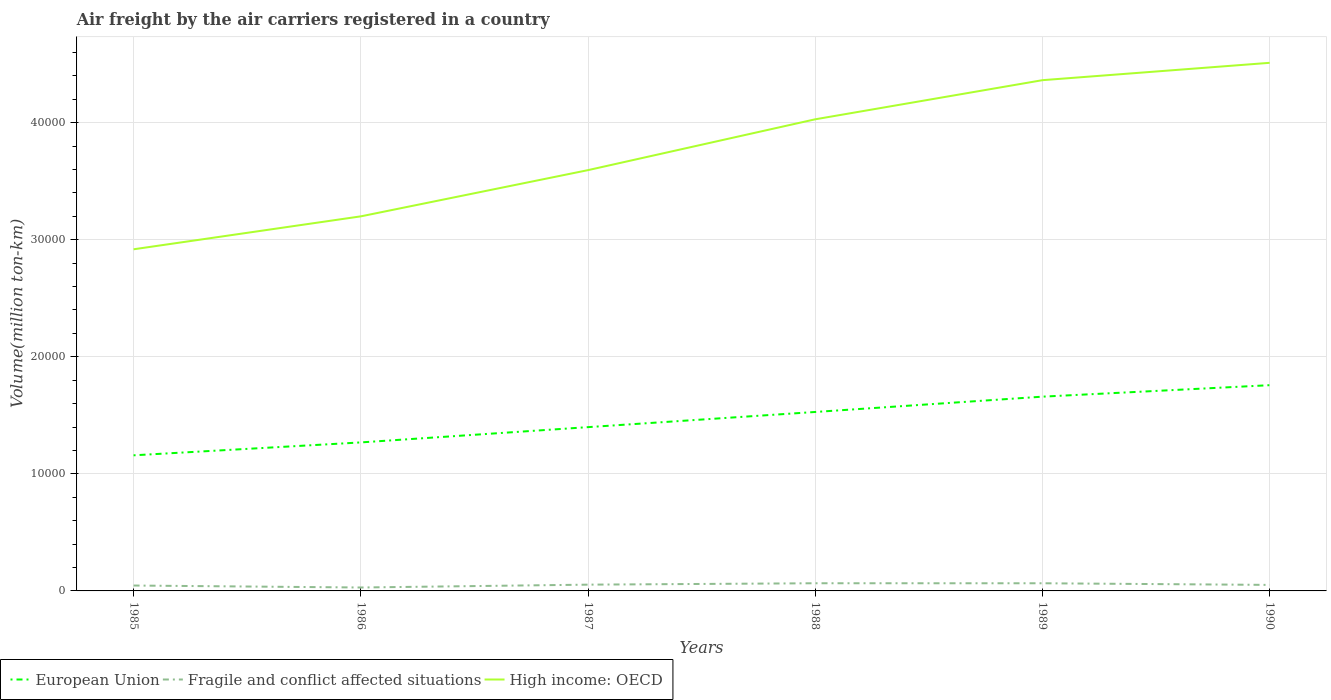Does the line corresponding to High income: OECD intersect with the line corresponding to European Union?
Your response must be concise. No. Across all years, what is the maximum volume of the air carriers in Fragile and conflict affected situations?
Give a very brief answer. 292. What is the total volume of the air carriers in Fragile and conflict affected situations in the graph?
Offer a very short reply. -54. What is the difference between the highest and the second highest volume of the air carriers in Fragile and conflict affected situations?
Offer a very short reply. 363.2. What is the difference between the highest and the lowest volume of the air carriers in European Union?
Ensure brevity in your answer.  3. Is the volume of the air carriers in European Union strictly greater than the volume of the air carriers in High income: OECD over the years?
Your response must be concise. Yes. How many lines are there?
Your answer should be compact. 3. How many years are there in the graph?
Offer a very short reply. 6. What is the difference between two consecutive major ticks on the Y-axis?
Provide a succinct answer. 10000. Does the graph contain any zero values?
Provide a succinct answer. No. Does the graph contain grids?
Make the answer very short. Yes. Where does the legend appear in the graph?
Your answer should be compact. Bottom left. How many legend labels are there?
Make the answer very short. 3. What is the title of the graph?
Give a very brief answer. Air freight by the air carriers registered in a country. What is the label or title of the X-axis?
Keep it short and to the point. Years. What is the label or title of the Y-axis?
Keep it short and to the point. Volume(million ton-km). What is the Volume(million ton-km) in European Union in 1985?
Provide a succinct answer. 1.16e+04. What is the Volume(million ton-km) in Fragile and conflict affected situations in 1985?
Your response must be concise. 460.4. What is the Volume(million ton-km) in High income: OECD in 1985?
Your answer should be very brief. 2.92e+04. What is the Volume(million ton-km) of European Union in 1986?
Give a very brief answer. 1.27e+04. What is the Volume(million ton-km) of Fragile and conflict affected situations in 1986?
Offer a very short reply. 292. What is the Volume(million ton-km) of High income: OECD in 1986?
Keep it short and to the point. 3.20e+04. What is the Volume(million ton-km) of European Union in 1987?
Ensure brevity in your answer.  1.40e+04. What is the Volume(million ton-km) in Fragile and conflict affected situations in 1987?
Ensure brevity in your answer.  536. What is the Volume(million ton-km) in High income: OECD in 1987?
Ensure brevity in your answer.  3.59e+04. What is the Volume(million ton-km) of European Union in 1988?
Offer a very short reply. 1.53e+04. What is the Volume(million ton-km) of Fragile and conflict affected situations in 1988?
Keep it short and to the point. 655.2. What is the Volume(million ton-km) in High income: OECD in 1988?
Make the answer very short. 4.03e+04. What is the Volume(million ton-km) of European Union in 1989?
Offer a very short reply. 1.66e+04. What is the Volume(million ton-km) of Fragile and conflict affected situations in 1989?
Your response must be concise. 653.9. What is the Volume(million ton-km) of High income: OECD in 1989?
Keep it short and to the point. 4.36e+04. What is the Volume(million ton-km) in European Union in 1990?
Provide a succinct answer. 1.76e+04. What is the Volume(million ton-km) in Fragile and conflict affected situations in 1990?
Offer a very short reply. 514.4. What is the Volume(million ton-km) in High income: OECD in 1990?
Keep it short and to the point. 4.51e+04. Across all years, what is the maximum Volume(million ton-km) in European Union?
Your response must be concise. 1.76e+04. Across all years, what is the maximum Volume(million ton-km) in Fragile and conflict affected situations?
Offer a very short reply. 655.2. Across all years, what is the maximum Volume(million ton-km) in High income: OECD?
Your answer should be compact. 4.51e+04. Across all years, what is the minimum Volume(million ton-km) of European Union?
Ensure brevity in your answer.  1.16e+04. Across all years, what is the minimum Volume(million ton-km) in Fragile and conflict affected situations?
Make the answer very short. 292. Across all years, what is the minimum Volume(million ton-km) of High income: OECD?
Provide a short and direct response. 2.92e+04. What is the total Volume(million ton-km) of European Union in the graph?
Ensure brevity in your answer.  8.77e+04. What is the total Volume(million ton-km) of Fragile and conflict affected situations in the graph?
Give a very brief answer. 3111.9. What is the total Volume(million ton-km) in High income: OECD in the graph?
Offer a very short reply. 2.26e+05. What is the difference between the Volume(million ton-km) of European Union in 1985 and that in 1986?
Provide a short and direct response. -1102.1. What is the difference between the Volume(million ton-km) of Fragile and conflict affected situations in 1985 and that in 1986?
Offer a terse response. 168.4. What is the difference between the Volume(million ton-km) in High income: OECD in 1985 and that in 1986?
Your answer should be very brief. -2812.8. What is the difference between the Volume(million ton-km) in European Union in 1985 and that in 1987?
Provide a short and direct response. -2407.5. What is the difference between the Volume(million ton-km) of Fragile and conflict affected situations in 1985 and that in 1987?
Provide a succinct answer. -75.6. What is the difference between the Volume(million ton-km) of High income: OECD in 1985 and that in 1987?
Offer a terse response. -6760.9. What is the difference between the Volume(million ton-km) in European Union in 1985 and that in 1988?
Provide a short and direct response. -3702.9. What is the difference between the Volume(million ton-km) in Fragile and conflict affected situations in 1985 and that in 1988?
Provide a succinct answer. -194.8. What is the difference between the Volume(million ton-km) of High income: OECD in 1985 and that in 1988?
Keep it short and to the point. -1.11e+04. What is the difference between the Volume(million ton-km) of European Union in 1985 and that in 1989?
Give a very brief answer. -5010.4. What is the difference between the Volume(million ton-km) of Fragile and conflict affected situations in 1985 and that in 1989?
Your response must be concise. -193.5. What is the difference between the Volume(million ton-km) of High income: OECD in 1985 and that in 1989?
Your response must be concise. -1.44e+04. What is the difference between the Volume(million ton-km) in European Union in 1985 and that in 1990?
Keep it short and to the point. -5991.1. What is the difference between the Volume(million ton-km) of Fragile and conflict affected situations in 1985 and that in 1990?
Offer a very short reply. -54. What is the difference between the Volume(million ton-km) in High income: OECD in 1985 and that in 1990?
Your answer should be compact. -1.59e+04. What is the difference between the Volume(million ton-km) in European Union in 1986 and that in 1987?
Your response must be concise. -1305.4. What is the difference between the Volume(million ton-km) of Fragile and conflict affected situations in 1986 and that in 1987?
Your response must be concise. -244. What is the difference between the Volume(million ton-km) of High income: OECD in 1986 and that in 1987?
Offer a very short reply. -3948.1. What is the difference between the Volume(million ton-km) of European Union in 1986 and that in 1988?
Provide a short and direct response. -2600.8. What is the difference between the Volume(million ton-km) in Fragile and conflict affected situations in 1986 and that in 1988?
Your response must be concise. -363.2. What is the difference between the Volume(million ton-km) in High income: OECD in 1986 and that in 1988?
Offer a very short reply. -8291.1. What is the difference between the Volume(million ton-km) in European Union in 1986 and that in 1989?
Your answer should be very brief. -3908.3. What is the difference between the Volume(million ton-km) in Fragile and conflict affected situations in 1986 and that in 1989?
Make the answer very short. -361.9. What is the difference between the Volume(million ton-km) of High income: OECD in 1986 and that in 1989?
Offer a very short reply. -1.16e+04. What is the difference between the Volume(million ton-km) of European Union in 1986 and that in 1990?
Provide a short and direct response. -4889. What is the difference between the Volume(million ton-km) of Fragile and conflict affected situations in 1986 and that in 1990?
Offer a very short reply. -222.4. What is the difference between the Volume(million ton-km) of High income: OECD in 1986 and that in 1990?
Offer a terse response. -1.31e+04. What is the difference between the Volume(million ton-km) of European Union in 1987 and that in 1988?
Provide a succinct answer. -1295.4. What is the difference between the Volume(million ton-km) of Fragile and conflict affected situations in 1987 and that in 1988?
Ensure brevity in your answer.  -119.2. What is the difference between the Volume(million ton-km) in High income: OECD in 1987 and that in 1988?
Your answer should be compact. -4343. What is the difference between the Volume(million ton-km) of European Union in 1987 and that in 1989?
Keep it short and to the point. -2602.9. What is the difference between the Volume(million ton-km) of Fragile and conflict affected situations in 1987 and that in 1989?
Ensure brevity in your answer.  -117.9. What is the difference between the Volume(million ton-km) in High income: OECD in 1987 and that in 1989?
Offer a very short reply. -7684.5. What is the difference between the Volume(million ton-km) in European Union in 1987 and that in 1990?
Your response must be concise. -3583.6. What is the difference between the Volume(million ton-km) in Fragile and conflict affected situations in 1987 and that in 1990?
Make the answer very short. 21.6. What is the difference between the Volume(million ton-km) of High income: OECD in 1987 and that in 1990?
Your answer should be very brief. -9167.5. What is the difference between the Volume(million ton-km) in European Union in 1988 and that in 1989?
Keep it short and to the point. -1307.5. What is the difference between the Volume(million ton-km) in High income: OECD in 1988 and that in 1989?
Give a very brief answer. -3341.5. What is the difference between the Volume(million ton-km) in European Union in 1988 and that in 1990?
Make the answer very short. -2288.2. What is the difference between the Volume(million ton-km) in Fragile and conflict affected situations in 1988 and that in 1990?
Make the answer very short. 140.8. What is the difference between the Volume(million ton-km) of High income: OECD in 1988 and that in 1990?
Your answer should be compact. -4824.5. What is the difference between the Volume(million ton-km) of European Union in 1989 and that in 1990?
Offer a very short reply. -980.7. What is the difference between the Volume(million ton-km) of Fragile and conflict affected situations in 1989 and that in 1990?
Your answer should be very brief. 139.5. What is the difference between the Volume(million ton-km) in High income: OECD in 1989 and that in 1990?
Make the answer very short. -1483. What is the difference between the Volume(million ton-km) in European Union in 1985 and the Volume(million ton-km) in Fragile and conflict affected situations in 1986?
Keep it short and to the point. 1.13e+04. What is the difference between the Volume(million ton-km) of European Union in 1985 and the Volume(million ton-km) of High income: OECD in 1986?
Ensure brevity in your answer.  -2.04e+04. What is the difference between the Volume(million ton-km) of Fragile and conflict affected situations in 1985 and the Volume(million ton-km) of High income: OECD in 1986?
Your response must be concise. -3.15e+04. What is the difference between the Volume(million ton-km) in European Union in 1985 and the Volume(million ton-km) in Fragile and conflict affected situations in 1987?
Offer a very short reply. 1.10e+04. What is the difference between the Volume(million ton-km) of European Union in 1985 and the Volume(million ton-km) of High income: OECD in 1987?
Provide a succinct answer. -2.44e+04. What is the difference between the Volume(million ton-km) in Fragile and conflict affected situations in 1985 and the Volume(million ton-km) in High income: OECD in 1987?
Provide a short and direct response. -3.55e+04. What is the difference between the Volume(million ton-km) of European Union in 1985 and the Volume(million ton-km) of Fragile and conflict affected situations in 1988?
Your answer should be very brief. 1.09e+04. What is the difference between the Volume(million ton-km) in European Union in 1985 and the Volume(million ton-km) in High income: OECD in 1988?
Provide a short and direct response. -2.87e+04. What is the difference between the Volume(million ton-km) of Fragile and conflict affected situations in 1985 and the Volume(million ton-km) of High income: OECD in 1988?
Provide a succinct answer. -3.98e+04. What is the difference between the Volume(million ton-km) in European Union in 1985 and the Volume(million ton-km) in Fragile and conflict affected situations in 1989?
Offer a very short reply. 1.09e+04. What is the difference between the Volume(million ton-km) of European Union in 1985 and the Volume(million ton-km) of High income: OECD in 1989?
Make the answer very short. -3.20e+04. What is the difference between the Volume(million ton-km) of Fragile and conflict affected situations in 1985 and the Volume(million ton-km) of High income: OECD in 1989?
Your answer should be very brief. -4.32e+04. What is the difference between the Volume(million ton-km) of European Union in 1985 and the Volume(million ton-km) of Fragile and conflict affected situations in 1990?
Your answer should be very brief. 1.11e+04. What is the difference between the Volume(million ton-km) in European Union in 1985 and the Volume(million ton-km) in High income: OECD in 1990?
Your response must be concise. -3.35e+04. What is the difference between the Volume(million ton-km) in Fragile and conflict affected situations in 1985 and the Volume(million ton-km) in High income: OECD in 1990?
Provide a short and direct response. -4.46e+04. What is the difference between the Volume(million ton-km) of European Union in 1986 and the Volume(million ton-km) of Fragile and conflict affected situations in 1987?
Make the answer very short. 1.21e+04. What is the difference between the Volume(million ton-km) of European Union in 1986 and the Volume(million ton-km) of High income: OECD in 1987?
Ensure brevity in your answer.  -2.33e+04. What is the difference between the Volume(million ton-km) of Fragile and conflict affected situations in 1986 and the Volume(million ton-km) of High income: OECD in 1987?
Provide a succinct answer. -3.57e+04. What is the difference between the Volume(million ton-km) of European Union in 1986 and the Volume(million ton-km) of Fragile and conflict affected situations in 1988?
Your answer should be compact. 1.20e+04. What is the difference between the Volume(million ton-km) of European Union in 1986 and the Volume(million ton-km) of High income: OECD in 1988?
Keep it short and to the point. -2.76e+04. What is the difference between the Volume(million ton-km) in Fragile and conflict affected situations in 1986 and the Volume(million ton-km) in High income: OECD in 1988?
Provide a short and direct response. -4.00e+04. What is the difference between the Volume(million ton-km) in European Union in 1986 and the Volume(million ton-km) in Fragile and conflict affected situations in 1989?
Provide a short and direct response. 1.20e+04. What is the difference between the Volume(million ton-km) of European Union in 1986 and the Volume(million ton-km) of High income: OECD in 1989?
Provide a short and direct response. -3.09e+04. What is the difference between the Volume(million ton-km) of Fragile and conflict affected situations in 1986 and the Volume(million ton-km) of High income: OECD in 1989?
Provide a succinct answer. -4.33e+04. What is the difference between the Volume(million ton-km) in European Union in 1986 and the Volume(million ton-km) in Fragile and conflict affected situations in 1990?
Ensure brevity in your answer.  1.22e+04. What is the difference between the Volume(million ton-km) of European Union in 1986 and the Volume(million ton-km) of High income: OECD in 1990?
Keep it short and to the point. -3.24e+04. What is the difference between the Volume(million ton-km) in Fragile and conflict affected situations in 1986 and the Volume(million ton-km) in High income: OECD in 1990?
Offer a terse response. -4.48e+04. What is the difference between the Volume(million ton-km) of European Union in 1987 and the Volume(million ton-km) of Fragile and conflict affected situations in 1988?
Provide a succinct answer. 1.33e+04. What is the difference between the Volume(million ton-km) in European Union in 1987 and the Volume(million ton-km) in High income: OECD in 1988?
Give a very brief answer. -2.63e+04. What is the difference between the Volume(million ton-km) in Fragile and conflict affected situations in 1987 and the Volume(million ton-km) in High income: OECD in 1988?
Provide a short and direct response. -3.97e+04. What is the difference between the Volume(million ton-km) of European Union in 1987 and the Volume(million ton-km) of Fragile and conflict affected situations in 1989?
Provide a short and direct response. 1.33e+04. What is the difference between the Volume(million ton-km) in European Union in 1987 and the Volume(million ton-km) in High income: OECD in 1989?
Offer a terse response. -2.96e+04. What is the difference between the Volume(million ton-km) in Fragile and conflict affected situations in 1987 and the Volume(million ton-km) in High income: OECD in 1989?
Give a very brief answer. -4.31e+04. What is the difference between the Volume(million ton-km) of European Union in 1987 and the Volume(million ton-km) of Fragile and conflict affected situations in 1990?
Ensure brevity in your answer.  1.35e+04. What is the difference between the Volume(million ton-km) in European Union in 1987 and the Volume(million ton-km) in High income: OECD in 1990?
Keep it short and to the point. -3.11e+04. What is the difference between the Volume(million ton-km) in Fragile and conflict affected situations in 1987 and the Volume(million ton-km) in High income: OECD in 1990?
Make the answer very short. -4.46e+04. What is the difference between the Volume(million ton-km) of European Union in 1988 and the Volume(million ton-km) of Fragile and conflict affected situations in 1989?
Your response must be concise. 1.46e+04. What is the difference between the Volume(million ton-km) in European Union in 1988 and the Volume(million ton-km) in High income: OECD in 1989?
Provide a succinct answer. -2.83e+04. What is the difference between the Volume(million ton-km) in Fragile and conflict affected situations in 1988 and the Volume(million ton-km) in High income: OECD in 1989?
Your answer should be compact. -4.30e+04. What is the difference between the Volume(million ton-km) of European Union in 1988 and the Volume(million ton-km) of Fragile and conflict affected situations in 1990?
Your response must be concise. 1.48e+04. What is the difference between the Volume(million ton-km) in European Union in 1988 and the Volume(million ton-km) in High income: OECD in 1990?
Keep it short and to the point. -2.98e+04. What is the difference between the Volume(million ton-km) of Fragile and conflict affected situations in 1988 and the Volume(million ton-km) of High income: OECD in 1990?
Provide a succinct answer. -4.45e+04. What is the difference between the Volume(million ton-km) of European Union in 1989 and the Volume(million ton-km) of Fragile and conflict affected situations in 1990?
Your answer should be compact. 1.61e+04. What is the difference between the Volume(million ton-km) in European Union in 1989 and the Volume(million ton-km) in High income: OECD in 1990?
Your response must be concise. -2.85e+04. What is the difference between the Volume(million ton-km) in Fragile and conflict affected situations in 1989 and the Volume(million ton-km) in High income: OECD in 1990?
Offer a very short reply. -4.45e+04. What is the average Volume(million ton-km) of European Union per year?
Provide a succinct answer. 1.46e+04. What is the average Volume(million ton-km) in Fragile and conflict affected situations per year?
Offer a very short reply. 518.65. What is the average Volume(million ton-km) in High income: OECD per year?
Your response must be concise. 3.77e+04. In the year 1985, what is the difference between the Volume(million ton-km) in European Union and Volume(million ton-km) in Fragile and conflict affected situations?
Provide a short and direct response. 1.11e+04. In the year 1985, what is the difference between the Volume(million ton-km) in European Union and Volume(million ton-km) in High income: OECD?
Give a very brief answer. -1.76e+04. In the year 1985, what is the difference between the Volume(million ton-km) of Fragile and conflict affected situations and Volume(million ton-km) of High income: OECD?
Offer a terse response. -2.87e+04. In the year 1986, what is the difference between the Volume(million ton-km) in European Union and Volume(million ton-km) in Fragile and conflict affected situations?
Ensure brevity in your answer.  1.24e+04. In the year 1986, what is the difference between the Volume(million ton-km) in European Union and Volume(million ton-km) in High income: OECD?
Your answer should be compact. -1.93e+04. In the year 1986, what is the difference between the Volume(million ton-km) of Fragile and conflict affected situations and Volume(million ton-km) of High income: OECD?
Provide a short and direct response. -3.17e+04. In the year 1987, what is the difference between the Volume(million ton-km) of European Union and Volume(million ton-km) of Fragile and conflict affected situations?
Offer a terse response. 1.35e+04. In the year 1987, what is the difference between the Volume(million ton-km) of European Union and Volume(million ton-km) of High income: OECD?
Provide a succinct answer. -2.20e+04. In the year 1987, what is the difference between the Volume(million ton-km) of Fragile and conflict affected situations and Volume(million ton-km) of High income: OECD?
Your answer should be very brief. -3.54e+04. In the year 1988, what is the difference between the Volume(million ton-km) in European Union and Volume(million ton-km) in Fragile and conflict affected situations?
Provide a succinct answer. 1.46e+04. In the year 1988, what is the difference between the Volume(million ton-km) of European Union and Volume(million ton-km) of High income: OECD?
Keep it short and to the point. -2.50e+04. In the year 1988, what is the difference between the Volume(million ton-km) in Fragile and conflict affected situations and Volume(million ton-km) in High income: OECD?
Your answer should be compact. -3.96e+04. In the year 1989, what is the difference between the Volume(million ton-km) of European Union and Volume(million ton-km) of Fragile and conflict affected situations?
Your response must be concise. 1.59e+04. In the year 1989, what is the difference between the Volume(million ton-km) in European Union and Volume(million ton-km) in High income: OECD?
Your answer should be compact. -2.70e+04. In the year 1989, what is the difference between the Volume(million ton-km) in Fragile and conflict affected situations and Volume(million ton-km) in High income: OECD?
Offer a terse response. -4.30e+04. In the year 1990, what is the difference between the Volume(million ton-km) in European Union and Volume(million ton-km) in Fragile and conflict affected situations?
Provide a short and direct response. 1.71e+04. In the year 1990, what is the difference between the Volume(million ton-km) in European Union and Volume(million ton-km) in High income: OECD?
Ensure brevity in your answer.  -2.75e+04. In the year 1990, what is the difference between the Volume(million ton-km) of Fragile and conflict affected situations and Volume(million ton-km) of High income: OECD?
Ensure brevity in your answer.  -4.46e+04. What is the ratio of the Volume(million ton-km) in European Union in 1985 to that in 1986?
Offer a very short reply. 0.91. What is the ratio of the Volume(million ton-km) in Fragile and conflict affected situations in 1985 to that in 1986?
Ensure brevity in your answer.  1.58. What is the ratio of the Volume(million ton-km) in High income: OECD in 1985 to that in 1986?
Offer a terse response. 0.91. What is the ratio of the Volume(million ton-km) in European Union in 1985 to that in 1987?
Ensure brevity in your answer.  0.83. What is the ratio of the Volume(million ton-km) of Fragile and conflict affected situations in 1985 to that in 1987?
Your response must be concise. 0.86. What is the ratio of the Volume(million ton-km) of High income: OECD in 1985 to that in 1987?
Provide a succinct answer. 0.81. What is the ratio of the Volume(million ton-km) in European Union in 1985 to that in 1988?
Give a very brief answer. 0.76. What is the ratio of the Volume(million ton-km) of Fragile and conflict affected situations in 1985 to that in 1988?
Your answer should be very brief. 0.7. What is the ratio of the Volume(million ton-km) of High income: OECD in 1985 to that in 1988?
Your response must be concise. 0.72. What is the ratio of the Volume(million ton-km) of European Union in 1985 to that in 1989?
Your answer should be very brief. 0.7. What is the ratio of the Volume(million ton-km) of Fragile and conflict affected situations in 1985 to that in 1989?
Ensure brevity in your answer.  0.7. What is the ratio of the Volume(million ton-km) in High income: OECD in 1985 to that in 1989?
Provide a short and direct response. 0.67. What is the ratio of the Volume(million ton-km) in European Union in 1985 to that in 1990?
Offer a very short reply. 0.66. What is the ratio of the Volume(million ton-km) in Fragile and conflict affected situations in 1985 to that in 1990?
Keep it short and to the point. 0.9. What is the ratio of the Volume(million ton-km) in High income: OECD in 1985 to that in 1990?
Your answer should be compact. 0.65. What is the ratio of the Volume(million ton-km) of European Union in 1986 to that in 1987?
Provide a succinct answer. 0.91. What is the ratio of the Volume(million ton-km) in Fragile and conflict affected situations in 1986 to that in 1987?
Your answer should be compact. 0.54. What is the ratio of the Volume(million ton-km) in High income: OECD in 1986 to that in 1987?
Ensure brevity in your answer.  0.89. What is the ratio of the Volume(million ton-km) of European Union in 1986 to that in 1988?
Provide a short and direct response. 0.83. What is the ratio of the Volume(million ton-km) of Fragile and conflict affected situations in 1986 to that in 1988?
Ensure brevity in your answer.  0.45. What is the ratio of the Volume(million ton-km) of High income: OECD in 1986 to that in 1988?
Make the answer very short. 0.79. What is the ratio of the Volume(million ton-km) of European Union in 1986 to that in 1989?
Ensure brevity in your answer.  0.76. What is the ratio of the Volume(million ton-km) of Fragile and conflict affected situations in 1986 to that in 1989?
Offer a terse response. 0.45. What is the ratio of the Volume(million ton-km) in High income: OECD in 1986 to that in 1989?
Make the answer very short. 0.73. What is the ratio of the Volume(million ton-km) of European Union in 1986 to that in 1990?
Keep it short and to the point. 0.72. What is the ratio of the Volume(million ton-km) in Fragile and conflict affected situations in 1986 to that in 1990?
Provide a short and direct response. 0.57. What is the ratio of the Volume(million ton-km) in High income: OECD in 1986 to that in 1990?
Offer a very short reply. 0.71. What is the ratio of the Volume(million ton-km) of European Union in 1987 to that in 1988?
Offer a very short reply. 0.92. What is the ratio of the Volume(million ton-km) of Fragile and conflict affected situations in 1987 to that in 1988?
Give a very brief answer. 0.82. What is the ratio of the Volume(million ton-km) in High income: OECD in 1987 to that in 1988?
Your answer should be compact. 0.89. What is the ratio of the Volume(million ton-km) in European Union in 1987 to that in 1989?
Offer a very short reply. 0.84. What is the ratio of the Volume(million ton-km) in Fragile and conflict affected situations in 1987 to that in 1989?
Give a very brief answer. 0.82. What is the ratio of the Volume(million ton-km) of High income: OECD in 1987 to that in 1989?
Ensure brevity in your answer.  0.82. What is the ratio of the Volume(million ton-km) of European Union in 1987 to that in 1990?
Keep it short and to the point. 0.8. What is the ratio of the Volume(million ton-km) in Fragile and conflict affected situations in 1987 to that in 1990?
Your answer should be very brief. 1.04. What is the ratio of the Volume(million ton-km) of High income: OECD in 1987 to that in 1990?
Offer a very short reply. 0.8. What is the ratio of the Volume(million ton-km) in European Union in 1988 to that in 1989?
Ensure brevity in your answer.  0.92. What is the ratio of the Volume(million ton-km) of High income: OECD in 1988 to that in 1989?
Your answer should be compact. 0.92. What is the ratio of the Volume(million ton-km) of European Union in 1988 to that in 1990?
Keep it short and to the point. 0.87. What is the ratio of the Volume(million ton-km) in Fragile and conflict affected situations in 1988 to that in 1990?
Offer a terse response. 1.27. What is the ratio of the Volume(million ton-km) in High income: OECD in 1988 to that in 1990?
Ensure brevity in your answer.  0.89. What is the ratio of the Volume(million ton-km) in European Union in 1989 to that in 1990?
Give a very brief answer. 0.94. What is the ratio of the Volume(million ton-km) of Fragile and conflict affected situations in 1989 to that in 1990?
Provide a succinct answer. 1.27. What is the ratio of the Volume(million ton-km) in High income: OECD in 1989 to that in 1990?
Make the answer very short. 0.97. What is the difference between the highest and the second highest Volume(million ton-km) in European Union?
Your response must be concise. 980.7. What is the difference between the highest and the second highest Volume(million ton-km) of Fragile and conflict affected situations?
Keep it short and to the point. 1.3. What is the difference between the highest and the second highest Volume(million ton-km) of High income: OECD?
Keep it short and to the point. 1483. What is the difference between the highest and the lowest Volume(million ton-km) in European Union?
Provide a short and direct response. 5991.1. What is the difference between the highest and the lowest Volume(million ton-km) of Fragile and conflict affected situations?
Provide a short and direct response. 363.2. What is the difference between the highest and the lowest Volume(million ton-km) in High income: OECD?
Make the answer very short. 1.59e+04. 